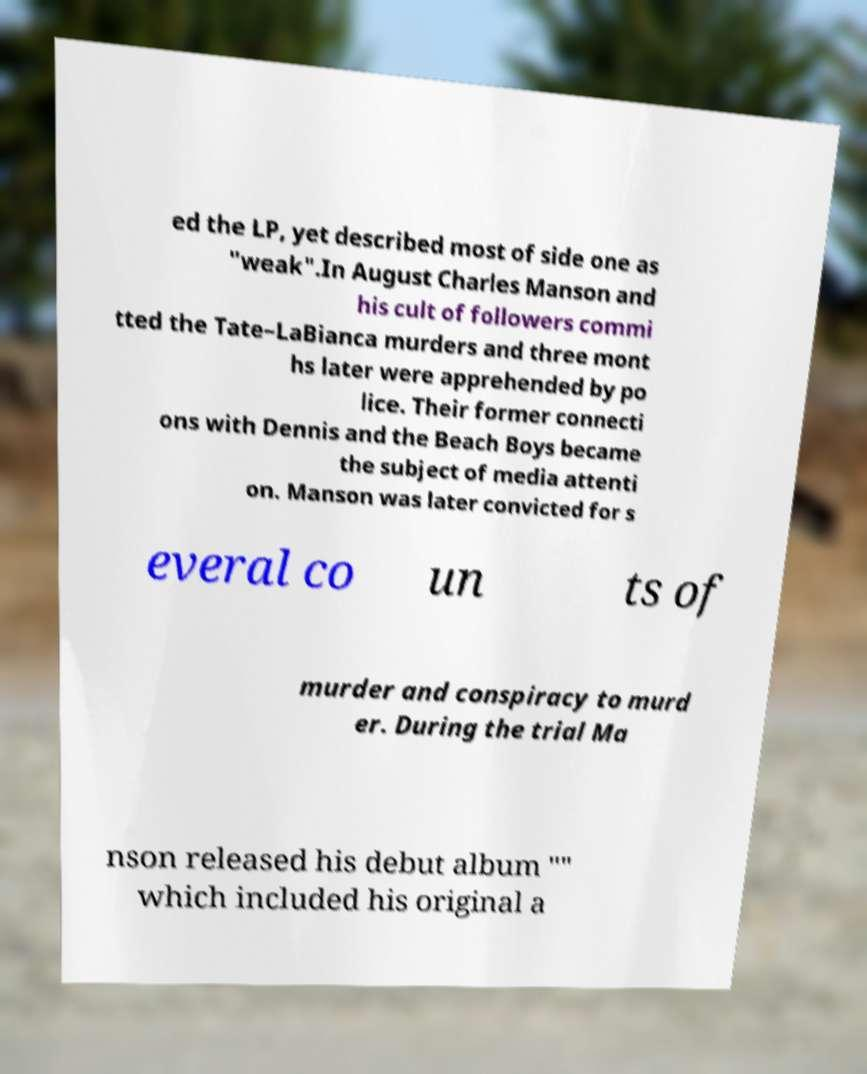For documentation purposes, I need the text within this image transcribed. Could you provide that? ed the LP, yet described most of side one as "weak".In August Charles Manson and his cult of followers commi tted the Tate–LaBianca murders and three mont hs later were apprehended by po lice. Their former connecti ons with Dennis and the Beach Boys became the subject of media attenti on. Manson was later convicted for s everal co un ts of murder and conspiracy to murd er. During the trial Ma nson released his debut album "" which included his original a 